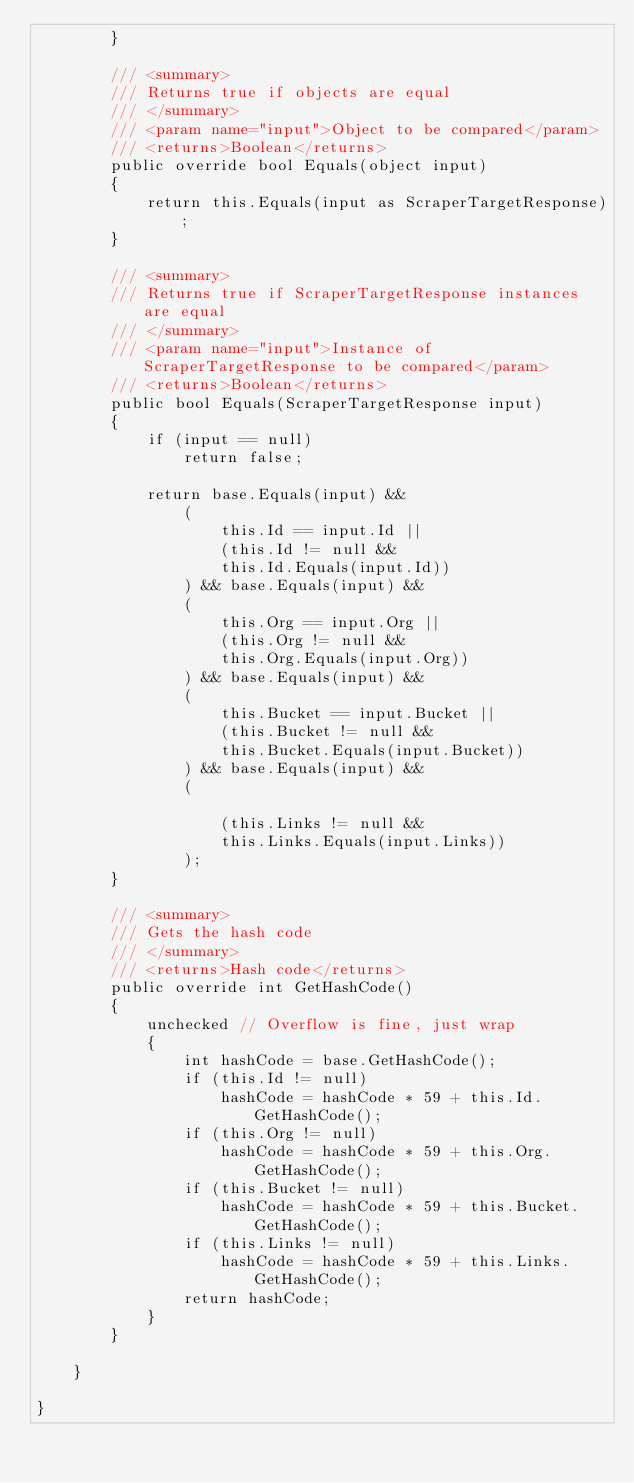<code> <loc_0><loc_0><loc_500><loc_500><_C#_>        }

        /// <summary>
        /// Returns true if objects are equal
        /// </summary>
        /// <param name="input">Object to be compared</param>
        /// <returns>Boolean</returns>
        public override bool Equals(object input)
        {
            return this.Equals(input as ScraperTargetResponse);
        }

        /// <summary>
        /// Returns true if ScraperTargetResponse instances are equal
        /// </summary>
        /// <param name="input">Instance of ScraperTargetResponse to be compared</param>
        /// <returns>Boolean</returns>
        public bool Equals(ScraperTargetResponse input)
        {
            if (input == null)
                return false;

            return base.Equals(input) && 
                (
                    this.Id == input.Id ||
                    (this.Id != null &&
                    this.Id.Equals(input.Id))
                ) && base.Equals(input) && 
                (
                    this.Org == input.Org ||
                    (this.Org != null &&
                    this.Org.Equals(input.Org))
                ) && base.Equals(input) && 
                (
                    this.Bucket == input.Bucket ||
                    (this.Bucket != null &&
                    this.Bucket.Equals(input.Bucket))
                ) && base.Equals(input) && 
                (
                    
                    (this.Links != null &&
                    this.Links.Equals(input.Links))
                );
        }

        /// <summary>
        /// Gets the hash code
        /// </summary>
        /// <returns>Hash code</returns>
        public override int GetHashCode()
        {
            unchecked // Overflow is fine, just wrap
            {
                int hashCode = base.GetHashCode();
                if (this.Id != null)
                    hashCode = hashCode * 59 + this.Id.GetHashCode();
                if (this.Org != null)
                    hashCode = hashCode * 59 + this.Org.GetHashCode();
                if (this.Bucket != null)
                    hashCode = hashCode * 59 + this.Bucket.GetHashCode();
                if (this.Links != null)
                    hashCode = hashCode * 59 + this.Links.GetHashCode();
                return hashCode;
            }
        }

    }

}
</code> 